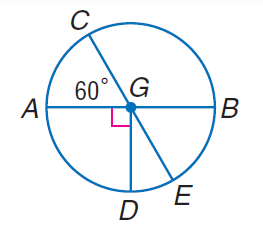Answer the mathemtical geometry problem and directly provide the correct option letter.
Question: Find m \angle A G E.
Choices: A: 60 B: 120 C: 210 D: 330 B 